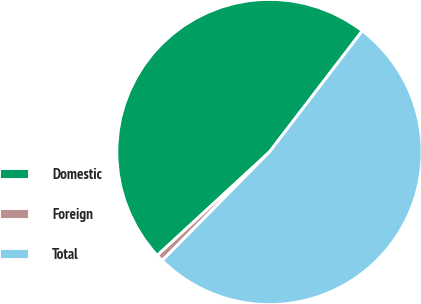Convert chart to OTSL. <chart><loc_0><loc_0><loc_500><loc_500><pie_chart><fcel>Domestic<fcel>Foreign<fcel>Total<nl><fcel>47.26%<fcel>0.74%<fcel>51.99%<nl></chart> 